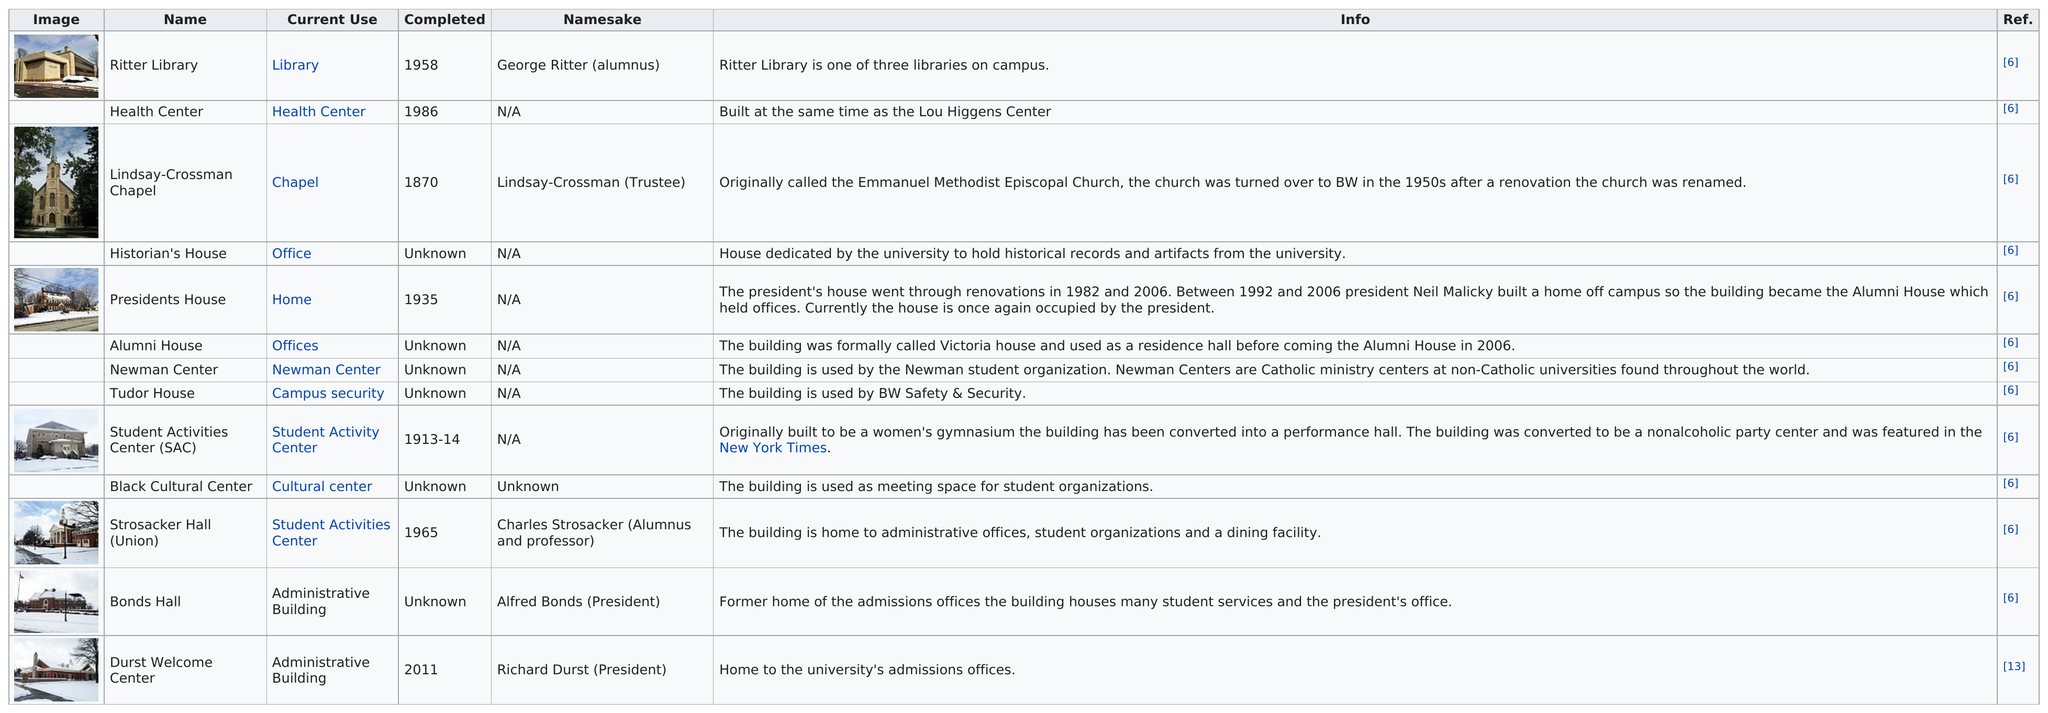Outline some significant characteristics in this image. In 1965, Strosacker Hall was constructed and not the President's House. The Alumni House, which was previously a residence hall, is a notable building that stands as a testament to the history of the institution. The total number of administrative buildings on the campus of BW is 13. The Durst Welcome Center is located after the Bonds Hall. There are six buildings on campus whose construction date is unknown. 